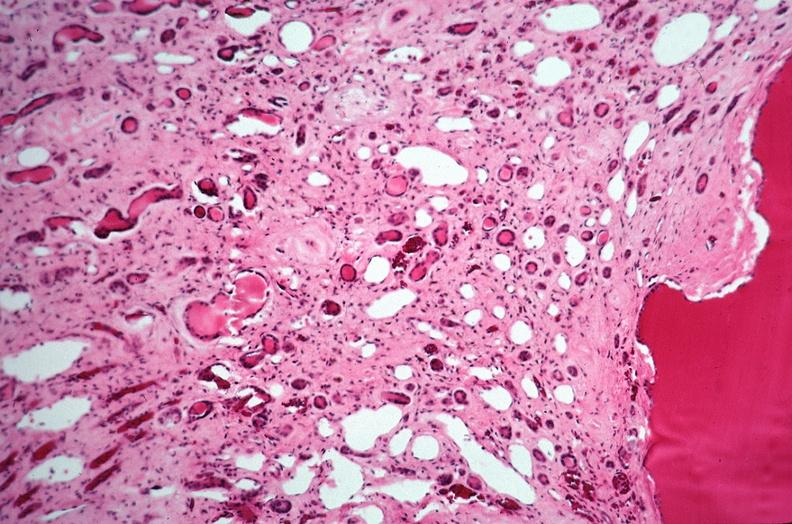what does this image show?
Answer the question using a single word or phrase. Kidney 